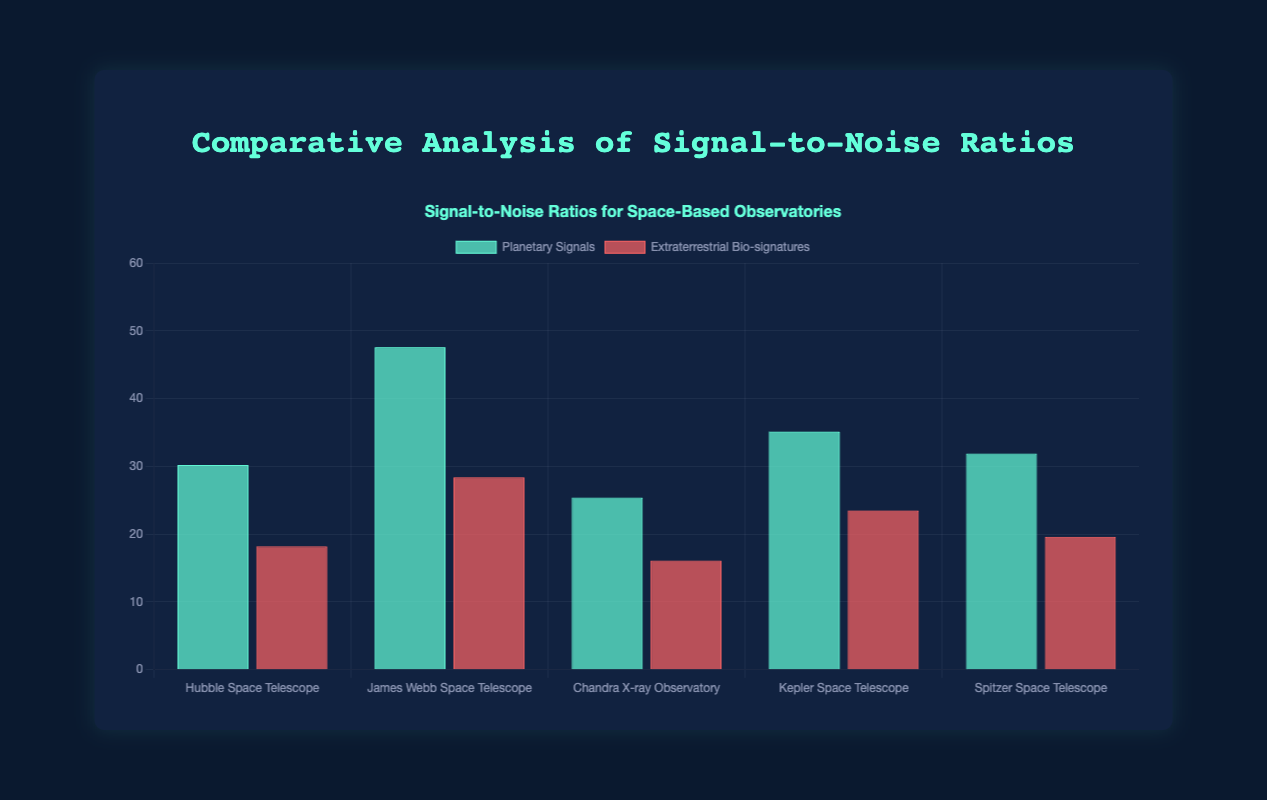What is the average Signal-to-Noise Ratio (SNR) for Planetary Signals detected by the Hubble Space Telescope? Sum the SNR values for Planetary Signals detected by the Hubble Space Telescope and divide by the number of values: (30.2 + 28.3 + 34.5 + 32.1 + 29.7) / 5 = 154.8 / 5 = 30.96
Answer: 30.96 Which observatory has the highest SNR for Planetary Signals? Compare the highest values of SNR for Planetary Signals across all observatories: Hubble (34.5), James Webb (50.2), Chandra (28.9), Kepler (40.7), Spitzer (35.0). The highest is for the James Webb Space Telescope with 50.2
Answer: James Webb Space Telescope Is the SNR for Extraterrestrial Bio-signatures detected by the Chandra X-ray Observatory higher or lower compared to Kepler Space Telescope? Compare the values: Chandra (16.1) and Kepler (23.5). 16.1 is lower than 23.5
Answer: Lower What is the difference between the highest and lowest SNR for Extraterrestrial Bio-signatures detected by the James Webb Space Telescope? Identify the highest and lowest values: Highest (31.8), Lowest (27.9). Subtract Lowest from Highest: 31.8 - 27.9 = 3.9
Answer: 3.9 Which observatory has the lowest average SNR for Extraterrestrial Bio-signatures? Calculate average SNR for each observatory for Extraterrestrial Bio-signatures and pick the lowest: Hubble ((18.2 + 19.8 + 17.6 + 20.4 + 18.7) / 5 = 18.94), James Webb ((28.4 + 30.2 + 29.6 + 31.8 + 27.9) / 5 = 29.58), Chandra ((16.1 + 17.2 + 15.8 + 18.1 + 16.9) / 5 = 16.82), Kepler ((23.5 + 25.1 + 21.7 + 24.3 + 22.8) / 5 = 23.48), Spitzer ((19.6 + 21.0 + 20.3 + 21.9 + 19.8) / 5 = 20.52). The lowest average SNR is for the Chandra X-ray Observatory (16.82)
Answer: Chandra X-ray Observatory How many observatories have an average SNR for Planetary Signals above 35? Calculate the average SNR for Planetary Signals for each observatory: Hubble (30.96), James Webb (47.22), Chandra (26.6), Kepler (36.56), Spitzer (32.12). Count the observatories with an average SNR above 35: James Webb and Kepler. Number of observatories meeting the criterion is 2
Answer: 2 Which has a higher SNR for Planetary Signals, the Kepler Space Telescope or the Spitzer Space Telescope? Compare the bar heights of the SNR values for Planetary Signals at Kepler (35.1) and Spitzer (31.9). Kepler's SNR (35.1) is higher
Answer: Kepler Space Telescope By how much does the SNR for Extraterrestrial Bio-signatures detected by the James Webb Space Telescope exceed the Spitzer Space Telescope? Find the difference between the SNR values for Extraterrestrial Bio-signatures detected by James Webb (28.4) and Spitzer (19.6): 28.4 - 19.6 = 8.8
Answer: 8.8 Which observatory shows the smallest variation in SNR for Planetary Signals? Calculate the range (maximum minus minimum) of SNR for Planetary Signals for each observatory: Hubble (34.5 - 28.3 = 6.2), James Webb (50.2 - 44.1 = 6.1), Chandra (28.9 - 24.9 = 4.0), Kepler (40.7 - 33.8 = 6.9), Spitzer (35.0 - 29.4 = 5.6). The smallest variation is for Chandra X-ray Observatory (4.0)
Answer: Chandra X-ray Observatory 